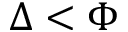<formula> <loc_0><loc_0><loc_500><loc_500>\Delta < \Phi</formula> 